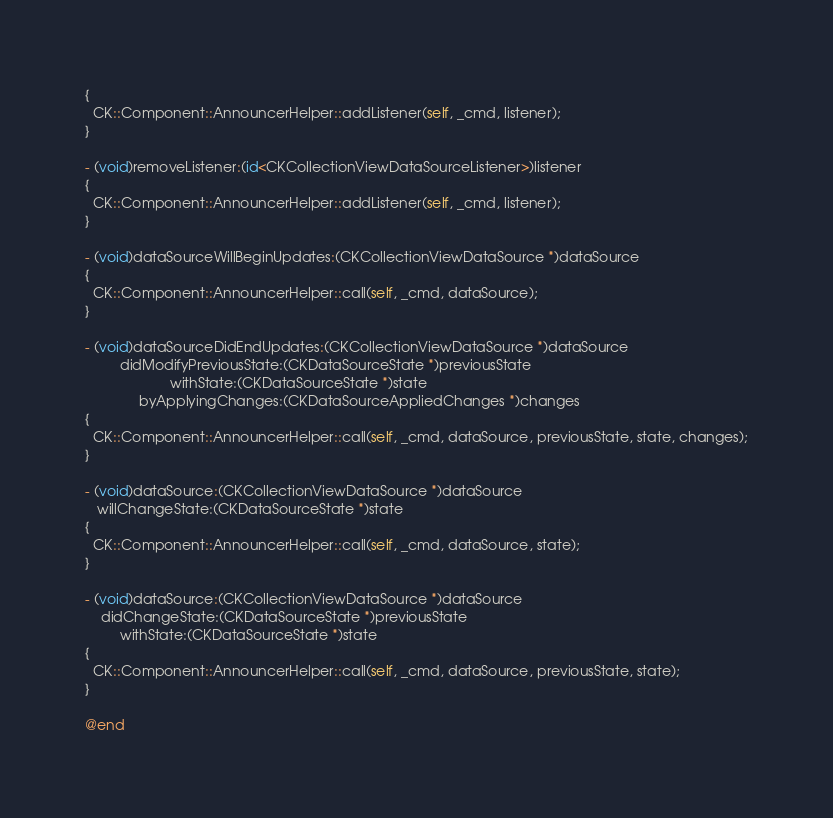Convert code to text. <code><loc_0><loc_0><loc_500><loc_500><_ObjectiveC_>{
  CK::Component::AnnouncerHelper::addListener(self, _cmd, listener);
}

- (void)removeListener:(id<CKCollectionViewDataSourceListener>)listener
{
  CK::Component::AnnouncerHelper::addListener(self, _cmd, listener);
}

- (void)dataSourceWillBeginUpdates:(CKCollectionViewDataSource *)dataSource
{
  CK::Component::AnnouncerHelper::call(self, _cmd, dataSource);
}

- (void)dataSourceDidEndUpdates:(CKCollectionViewDataSource *)dataSource
         didModifyPreviousState:(CKDataSourceState *)previousState
                      withState:(CKDataSourceState *)state
              byApplyingChanges:(CKDataSourceAppliedChanges *)changes
{
  CK::Component::AnnouncerHelper::call(self, _cmd, dataSource, previousState, state, changes);
}

- (void)dataSource:(CKCollectionViewDataSource *)dataSource
   willChangeState:(CKDataSourceState *)state
{
  CK::Component::AnnouncerHelper::call(self, _cmd, dataSource, state);
}

- (void)dataSource:(CKCollectionViewDataSource *)dataSource
    didChangeState:(CKDataSourceState *)previousState
         withState:(CKDataSourceState *)state
{
  CK::Component::AnnouncerHelper::call(self, _cmd, dataSource, previousState, state);
}

@end
</code> 